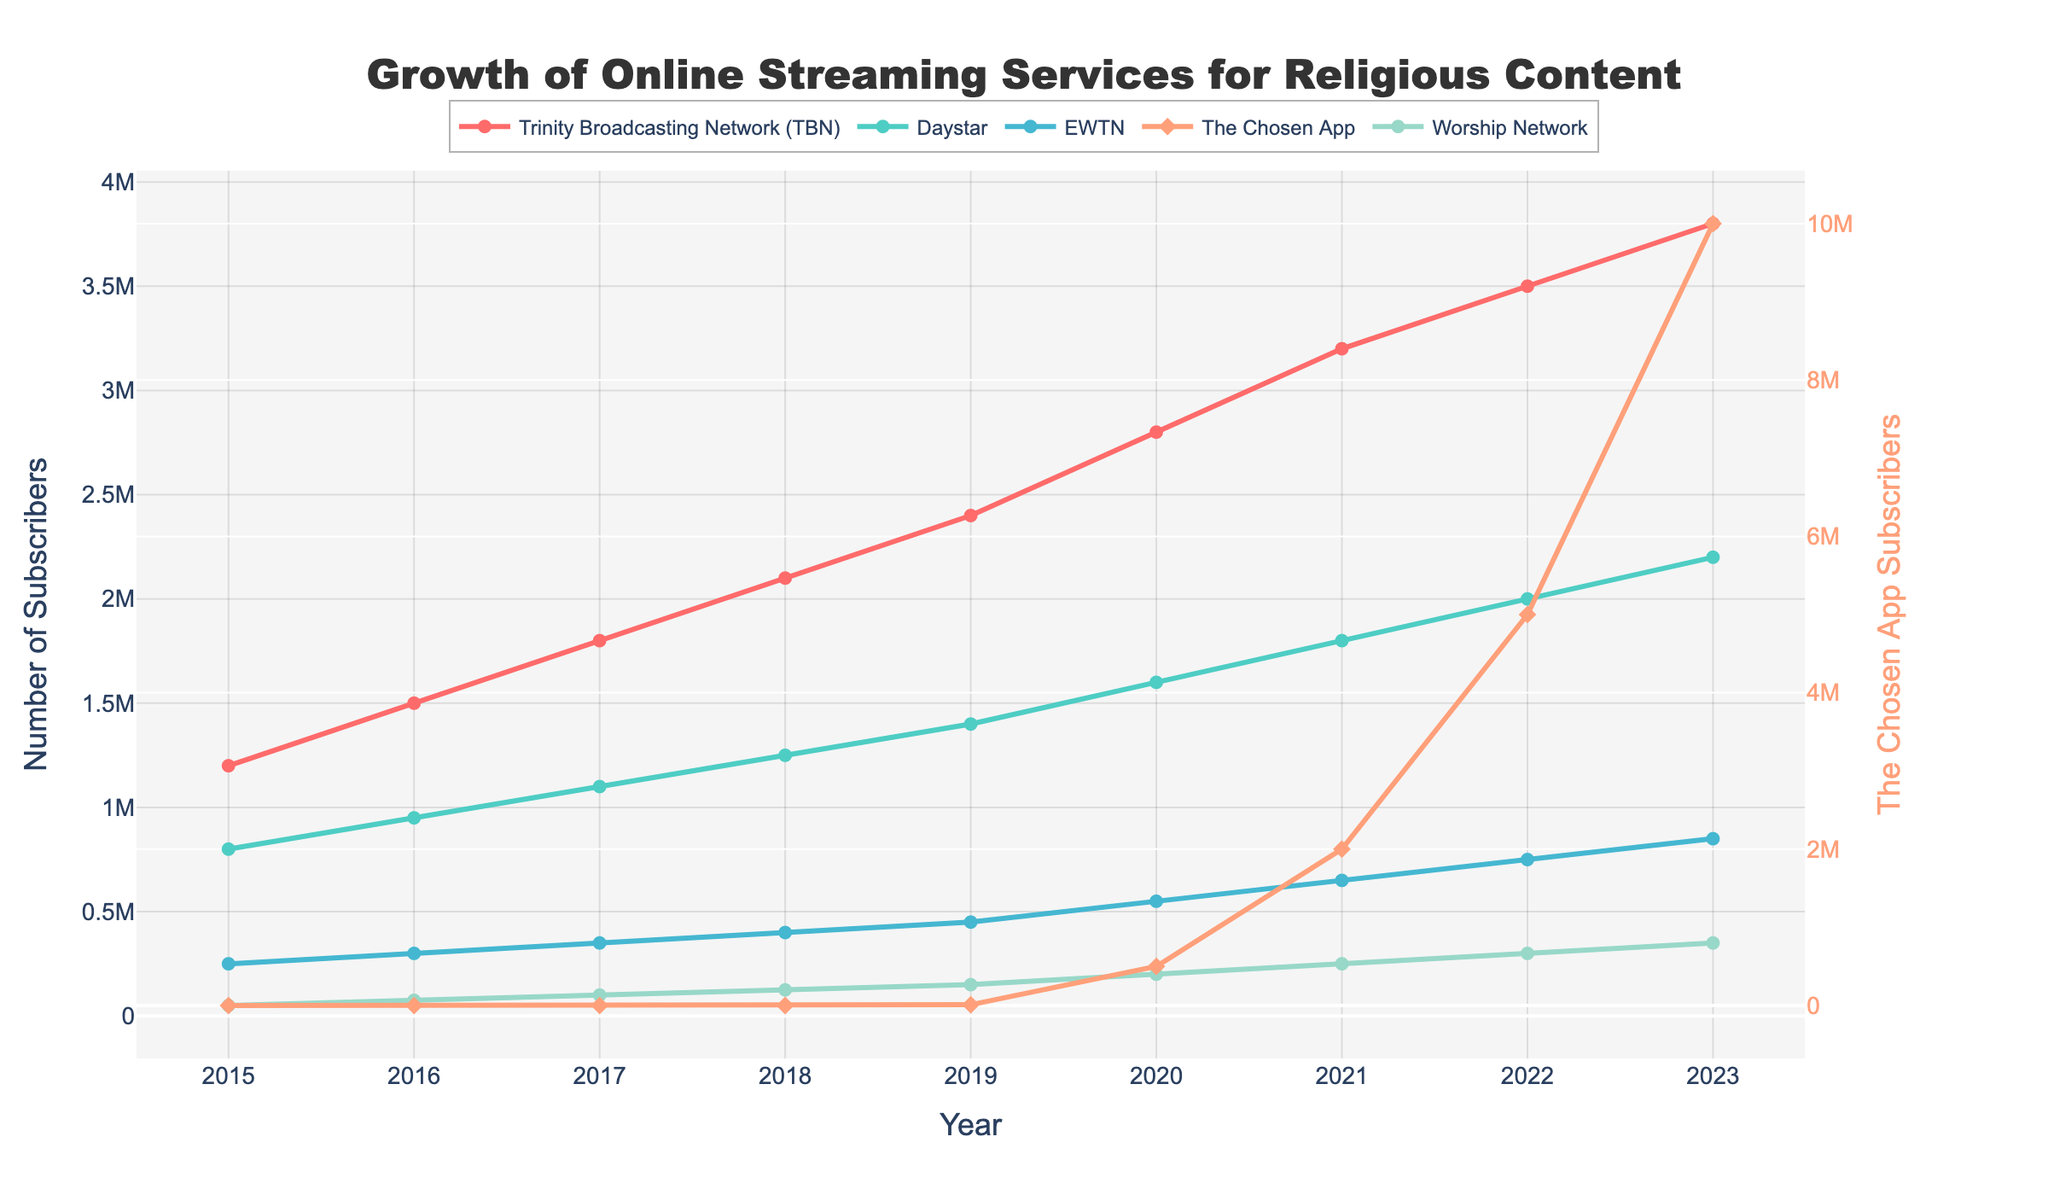What's the trend in the number of subscribers for Trinity Broadcasting Network (TBN) from 2015 to 2023? The number of subscribers for TBN increased each year from 1,200,000 in 2015 to 3,800,000 in 2023.
Answer: Increasing Which streaming service had the highest growth rate in subscribers between 2020 and 2023? The Chosen App had the highest growth rate, increasing from 500,000 subscribers in 2020 to 10,000,000 in 2023.
Answer: The Chosen App How does the number of subscribers for Daystar in 2020 compare to EWTN in 2021? In 2020, Daystar had 1,600,000 subscribers while EWTN had 650,000 in 2021. Comparing these, Daystar had higher subscribers.
Answer: Daystar had higher What's the combined number of subscribers for Worship Network and Daystar in 2023? In 2023, Worship Network had 350,000 and Daystar had 2,200,000 subscribers. The combined number is 350,000 + 2,200,000 = 2,550,000.
Answer: 2,550,000 In which year did The Chosen App start gaining subscribers, and how many did it have in that year? The Chosen App started gaining subscribers in 2019 with 10,000 subscribers.
Answer: 2019, 10,000 Across all the years, which service has shown the slowest growth in subscriber count? EWTN has shown a relatively slow and steady growth, increasing from 250,000 in 2015 to 850,000 in 2023.
Answer: EWTN What's the difference in the number of subscribers between TBN and Daystar in 2023? In 2023, TBN had 3,800,000 subscribers and Daystar had 2,200,000 subscribers. The difference is 3,800,000 - 2,200,000 = 1,600,000.
Answer: 1,600,000 What visual marker is used to represent The Chosen App data? The Chosen App data is represented with lines and diamond-shaped markers.
Answer: Lines with diamond markers 